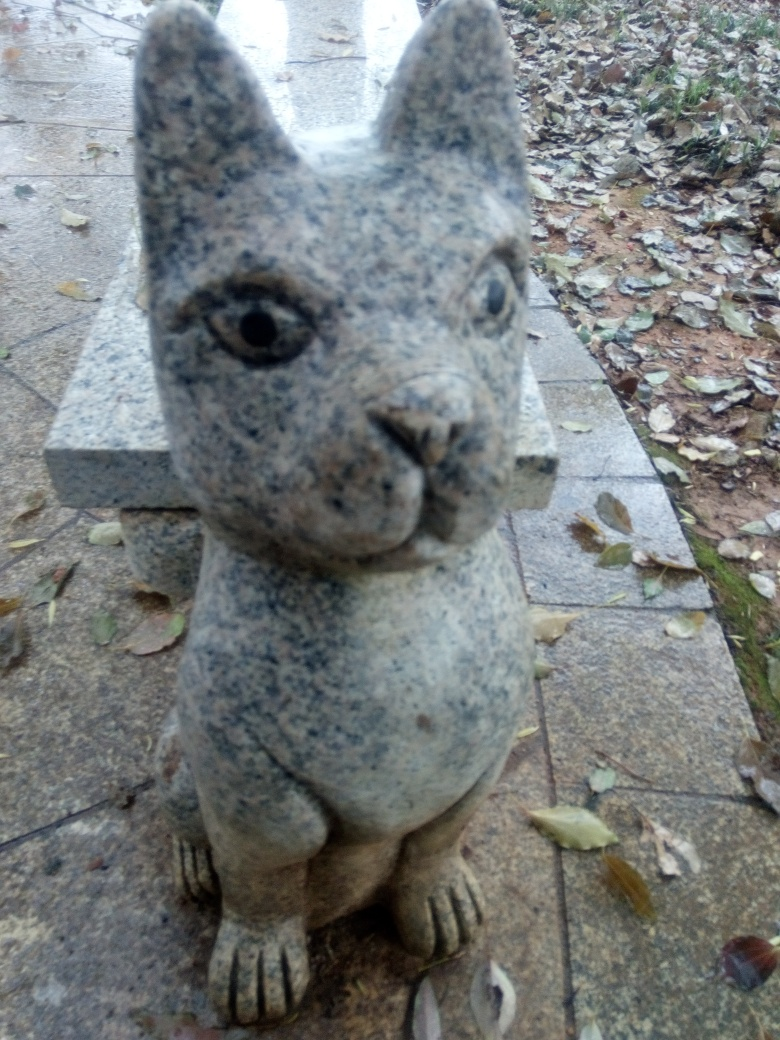Can you tell me about the object in the photo? The object in the photo appears to be a sculpture of a squirrel, likely made from stone or a similar material given its textured surface and color variations. It has a stylized design and seems to be placed outdoors, as suggested by the natural debris and leaf-littered ground around it. 